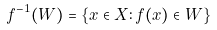Convert formula to latex. <formula><loc_0><loc_0><loc_500><loc_500>f ^ { - 1 } ( W ) = \{ x \in X \colon f ( x ) \in W \}</formula> 